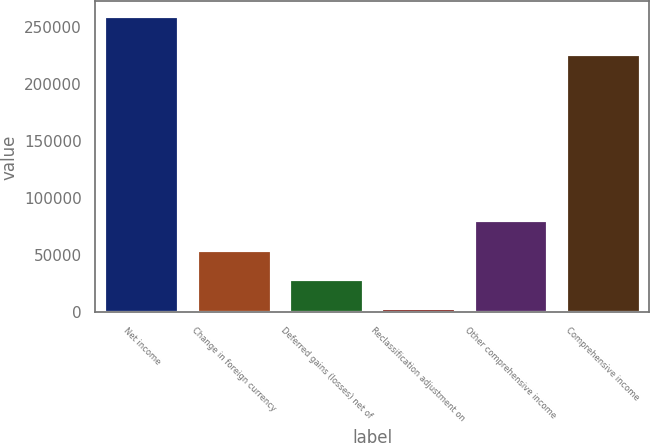Convert chart to OTSL. <chart><loc_0><loc_0><loc_500><loc_500><bar_chart><fcel>Net income<fcel>Change in foreign currency<fcel>Deferred gains (losses) net of<fcel>Reclassification adjustment on<fcel>Other comprehensive income<fcel>Comprehensive income<nl><fcel>259124<fcel>54930.4<fcel>29406.2<fcel>3882<fcel>80454.6<fcel>225730<nl></chart> 